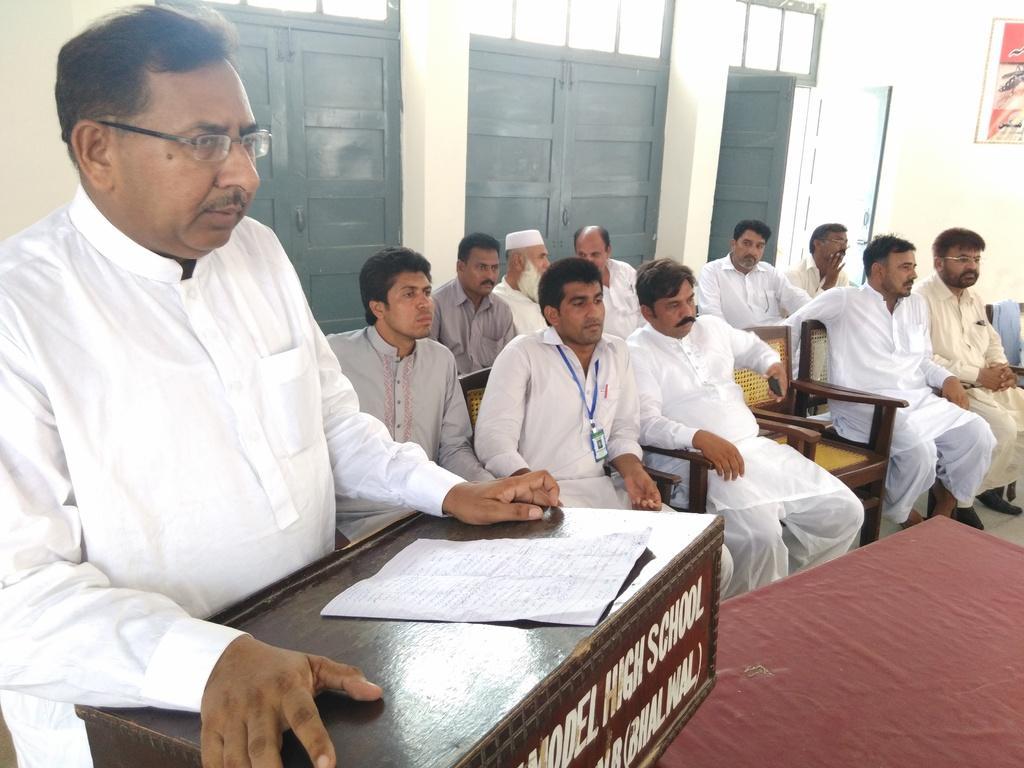Please provide a concise description of this image. In the image we can see there are people sitting and one is standing. They are wearing clothes and some of them are wearing spectacles. Here we can see the podium and on it there is a paper and text. Here we can see the door and the wall. 